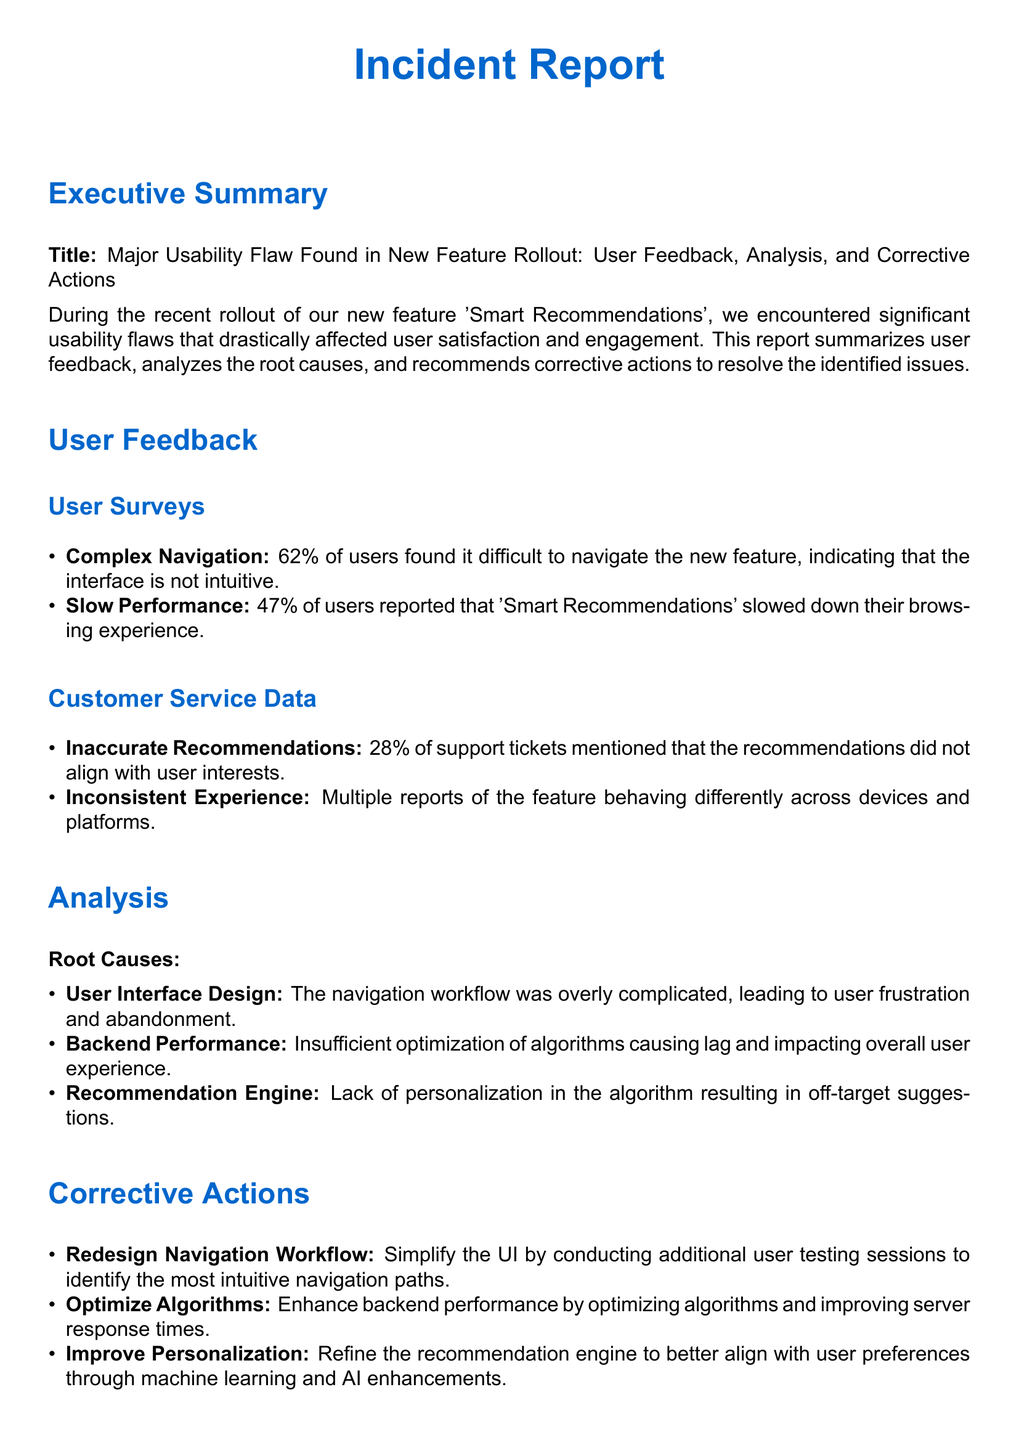What is the major issue identified in the report? The report identifies a major usability flaw found in the 'Smart Recommendations' feature rollout.
Answer: Usability flaw What percentage of users found navigation difficult? The user survey indicates that 62% of users found it difficult to navigate the new feature.
Answer: 62% Which team is responsible for the redesign phase? The report specifies that the UI/UX Design Team is responsible for initiating the redesign phase.
Answer: UI/UX Design Team How many support tickets mentioned inaccurate recommendations? The report states that 28% of support tickets mentioned that the recommendations did not align with user interests.
Answer: 28% What is one of the root causes of the usability issues? One of the root causes is the overly complicated navigation workflow in the user interface design.
Answer: Complicated navigation workflow What is the deadline for algorithm optimization? According to the report, the deadline for algorithm optimization is within 1 month.
Answer: Within 1 month What corrective action is recommended for improving personalization? The report recommends refining the recommendation engine for better alignment with user preferences through enhancements.
Answer: Improve personalization What is the expected timeframe for the full rollout? The report outlines that the full rollout is expected within 2 months after taking corrective actions.
Answer: Within 2 months 